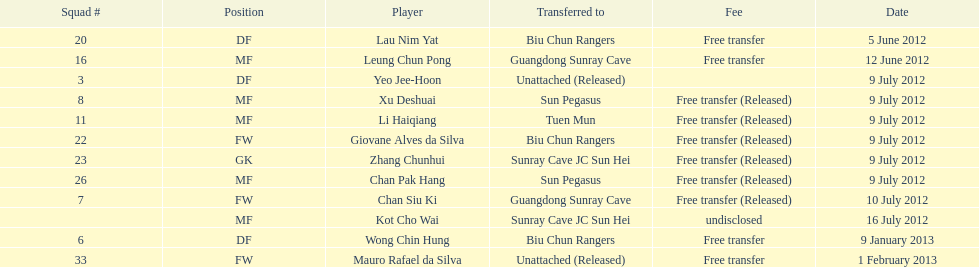What team number is mentioned before team number 7? 26. 